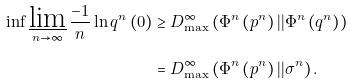<formula> <loc_0><loc_0><loc_500><loc_500>\inf \varliminf _ { n \rightarrow \infty } \frac { - 1 } { n } \ln q ^ { n } \left ( 0 \right ) & \geq D _ { \max } ^ { \infty } \left ( \Phi ^ { n } \left ( p ^ { n } \right ) | | \Phi ^ { n } \left ( q ^ { n } \right ) \right ) \\ & = D _ { \max } ^ { \infty } \left ( \Phi ^ { n } \left ( p ^ { n } \right ) | | \sigma ^ { n } \right ) .</formula> 